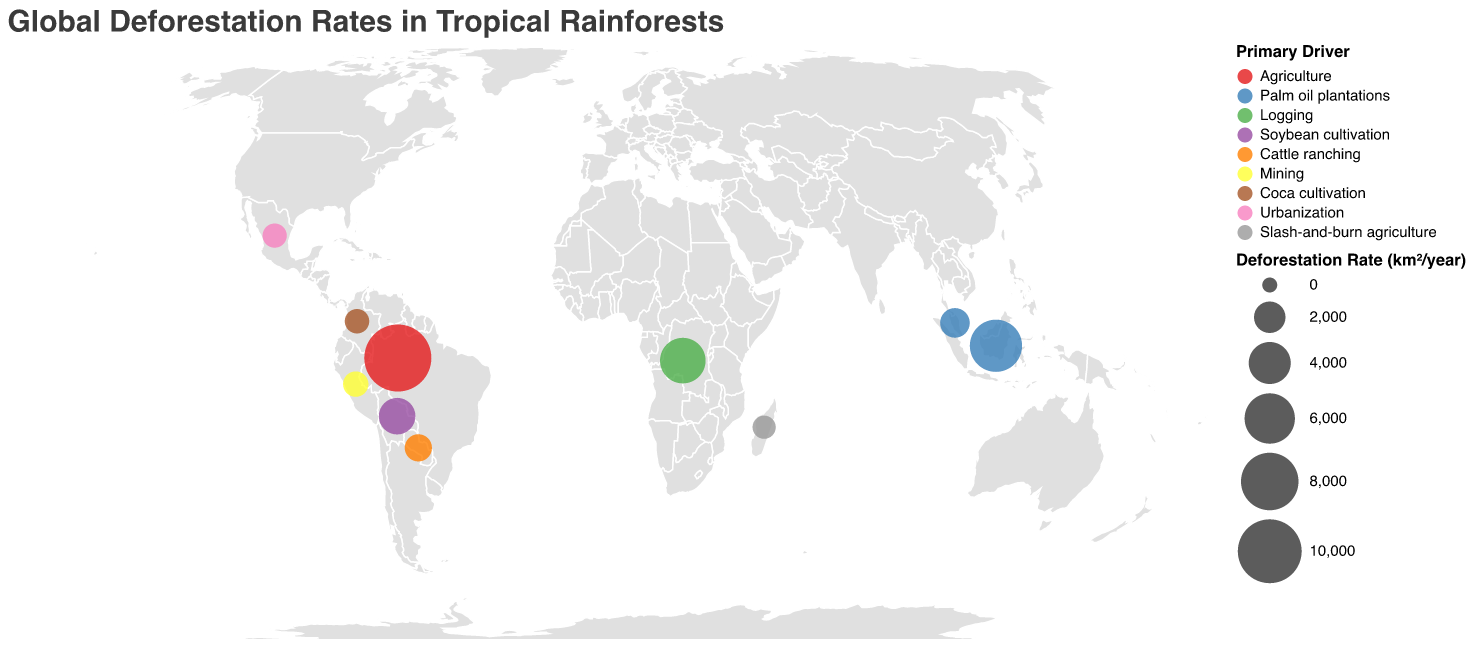What is the title of the figure? The title is displayed at the top of the figure and reads "Global Deforestation Rates in Tropical Rainforests."
Answer: Global Deforestation Rates in Tropical Rainforests Which country has the highest deforestation rate according to the figure? From the circle sizes shown in the figure, the largest circle represents Brazil, which corresponds to the highest deforestation rate among the listed countries.
Answer: Brazil What is the primary driver for deforestation in Malaysia? From the color legend and the circle color for Malaysia, the primary driver can be matched. Malaysia's circle color corresponds to palm oil plantations.
Answer: Palm oil plantations Compare the deforestation rates between Indonesia and Malaysia. Which country has a higher rate? By comparing the sizes of the circles for both countries, Indonesia has a larger circle than Malaysia, indicating a higher deforestation rate.
Answer: Indonesia Based on the data provided in the figure, calculate the average deforestation rate among all listed countries. Sum up the deforestation rates for all listed countries (11088 + 6500 + 4810 + 2900 + 1700 + 1350 + 1100 + 980 + 950 + 820 = 31998) and divide by the number of countries (10).
Answer: 3199.8 How many countries in the plot have agriculture as the primary driver of deforestation? From the color legend and the corresponding circles, only Brazil has agriculture listed as the primary driver.
Answer: 1 What continents can you infer the listed countries are located on based on their deforestation issues? The countries listed come from various continents: South America (Brazil, Bolivia, Paraguay, Peru, Colombia), Africa (Democratic Republic of Congo, Madagascar), and Asia (Indonesia, Malaysia).
Answer: South America, Africa, Asia What is the total deforestation rate for the countries in the South American continent? Sum up the deforestation rates for Brazil, Bolivia, Paraguay, Peru, and Colombia (11088 + 2900 + 1350 + 1100 + 980 = 17418).
Answer: 17418 Identify the countries whose primary driver of deforestation is related to agricultural practices, including specific types of plantations or farming. By checking the primary drivers, the countries are Brazil (Agriculture), Indonesia (Palm oil plantations), Malaysia (Palm oil plantations), Bolivia (Soybean cultivation), and Paraguay (Cattle ranching).
Answer: Brazil, Indonesia, Malaysia, Bolivia, Paraguay Arrange the countries by deforestation rate in descending order. List the countries by their rates from high to low: Brazil (11088), Indonesia (6500), Democratic Republic of Congo (4810), Bolivia (2900), Malaysia (1700), Paraguay (1350), Peru (1100), Colombia (980), Mexico (950), Madagascar (820).
Answer: Brazil, Indonesia, Democratic Republic of Congo, Bolivia, Malaysia, Paraguay, Peru, Colombia, Mexico, Madagascar 